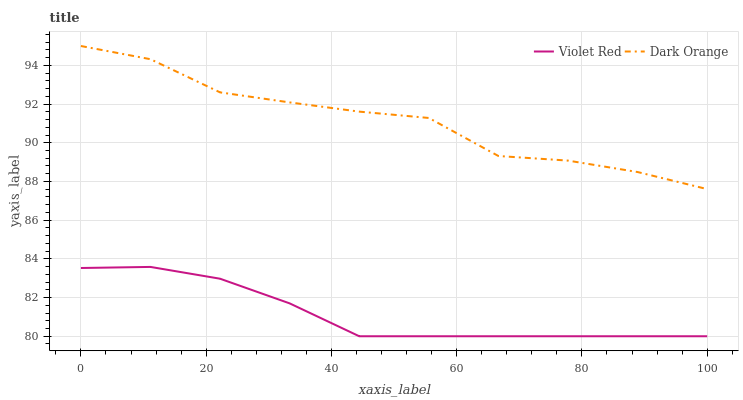Does Violet Red have the minimum area under the curve?
Answer yes or no. Yes. Does Dark Orange have the maximum area under the curve?
Answer yes or no. Yes. Does Violet Red have the maximum area under the curve?
Answer yes or no. No. Is Violet Red the smoothest?
Answer yes or no. Yes. Is Dark Orange the roughest?
Answer yes or no. Yes. Is Violet Red the roughest?
Answer yes or no. No. Does Violet Red have the lowest value?
Answer yes or no. Yes. Does Dark Orange have the highest value?
Answer yes or no. Yes. Does Violet Red have the highest value?
Answer yes or no. No. Is Violet Red less than Dark Orange?
Answer yes or no. Yes. Is Dark Orange greater than Violet Red?
Answer yes or no. Yes. Does Violet Red intersect Dark Orange?
Answer yes or no. No. 